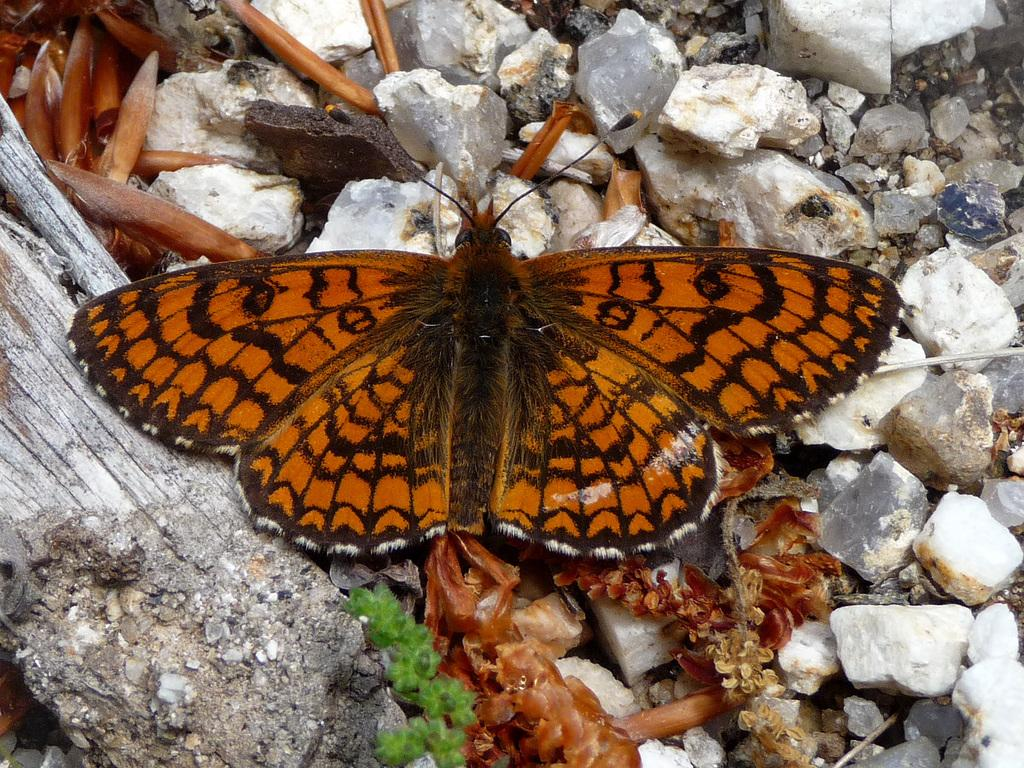What type of animal can be seen in the image? There is a butterfly in the image. What is visible beneath the butterfly? The ground is visible in the image. What can be found on the ground in the image? There are stones, leaves, and other objects on the ground. What is located on the left side of the image? There is wood on the left side of the image. What type of pain is the butterfly experiencing in the image? There is no indication of pain in the image; the butterfly appears to be flying or resting peacefully. 